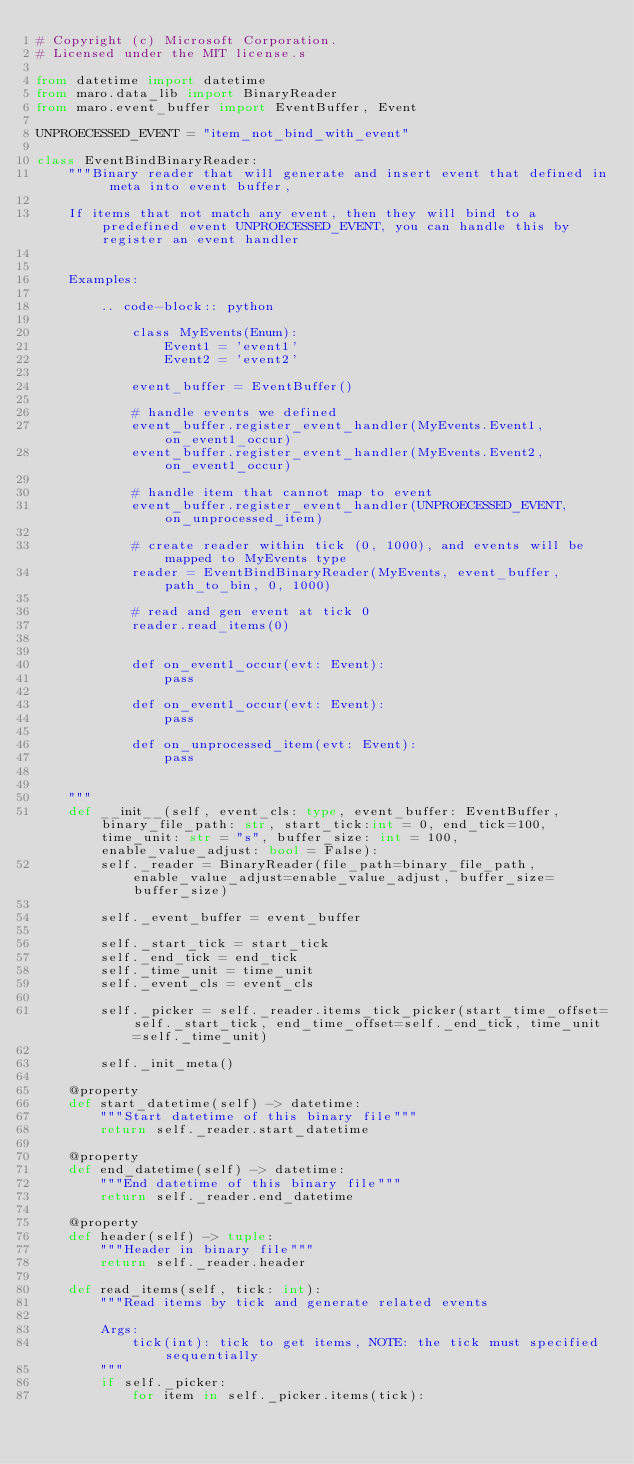Convert code to text. <code><loc_0><loc_0><loc_500><loc_500><_Python_># Copyright (c) Microsoft Corporation.
# Licensed under the MIT license.s

from datetime import datetime
from maro.data_lib import BinaryReader
from maro.event_buffer import EventBuffer, Event

UNPROECESSED_EVENT = "item_not_bind_with_event"

class EventBindBinaryReader:
    """Binary reader that will generate and insert event that defined in meta into event buffer,
    
    If items that not match any event, then they will bind to a predefined event UNPROECESSED_EVENT, you can handle this by register an event handler
    
    
    Examples:

        .. code-block:: python

            class MyEvents(Enum):
                Event1 = 'event1'
                Event2 = 'event2'

            event_buffer = EventBuffer()

            # handle events we defined
            event_buffer.register_event_handler(MyEvents.Event1, on_event1_occur)
            event_buffer.register_event_handler(MyEvents.Event2, on_event1_occur)

            # handle item that cannot map to event
            event_buffer.register_event_handler(UNPROECESSED_EVENT, on_unprocessed_item)

            # create reader within tick (0, 1000), and events will be mapped to MyEvents type
            reader = EventBindBinaryReader(MyEvents, event_buffer, path_to_bin, 0, 1000)

            # read and gen event at tick 0
            reader.read_items(0)


            def on_event1_occur(evt: Event):
                pass

            def on_event1_occur(evt: Event):
                pass

            def on_unprocessed_item(evt: Event):
                pass

    
    """
    def __init__(self, event_cls: type, event_buffer: EventBuffer, binary_file_path: str, start_tick:int = 0, end_tick=100, time_unit: str = "s", buffer_size: int = 100, enable_value_adjust: bool = False):
        self._reader = BinaryReader(file_path=binary_file_path, enable_value_adjust=enable_value_adjust, buffer_size=buffer_size)

        self._event_buffer = event_buffer

        self._start_tick = start_tick
        self._end_tick = end_tick
        self._time_unit = time_unit
        self._event_cls = event_cls

        self._picker = self._reader.items_tick_picker(start_time_offset=self._start_tick, end_time_offset=self._end_tick, time_unit=self._time_unit)

        self._init_meta()

    @property
    def start_datetime(self) -> datetime:
        """Start datetime of this binary file"""
        return self._reader.start_datetime

    @property
    def end_datetime(self) -> datetime:
        """End datetime of this binary file"""
        return self._reader.end_datetime

    @property
    def header(self) -> tuple:
        """Header in binary file"""
        return self._reader.header

    def read_items(self, tick: int):
        """Read items by tick and generate related events
        
        Args:
            tick(int): tick to get items, NOTE: the tick must specified sequentially
        """
        if self._picker:
            for item in self._picker.items(tick):</code> 